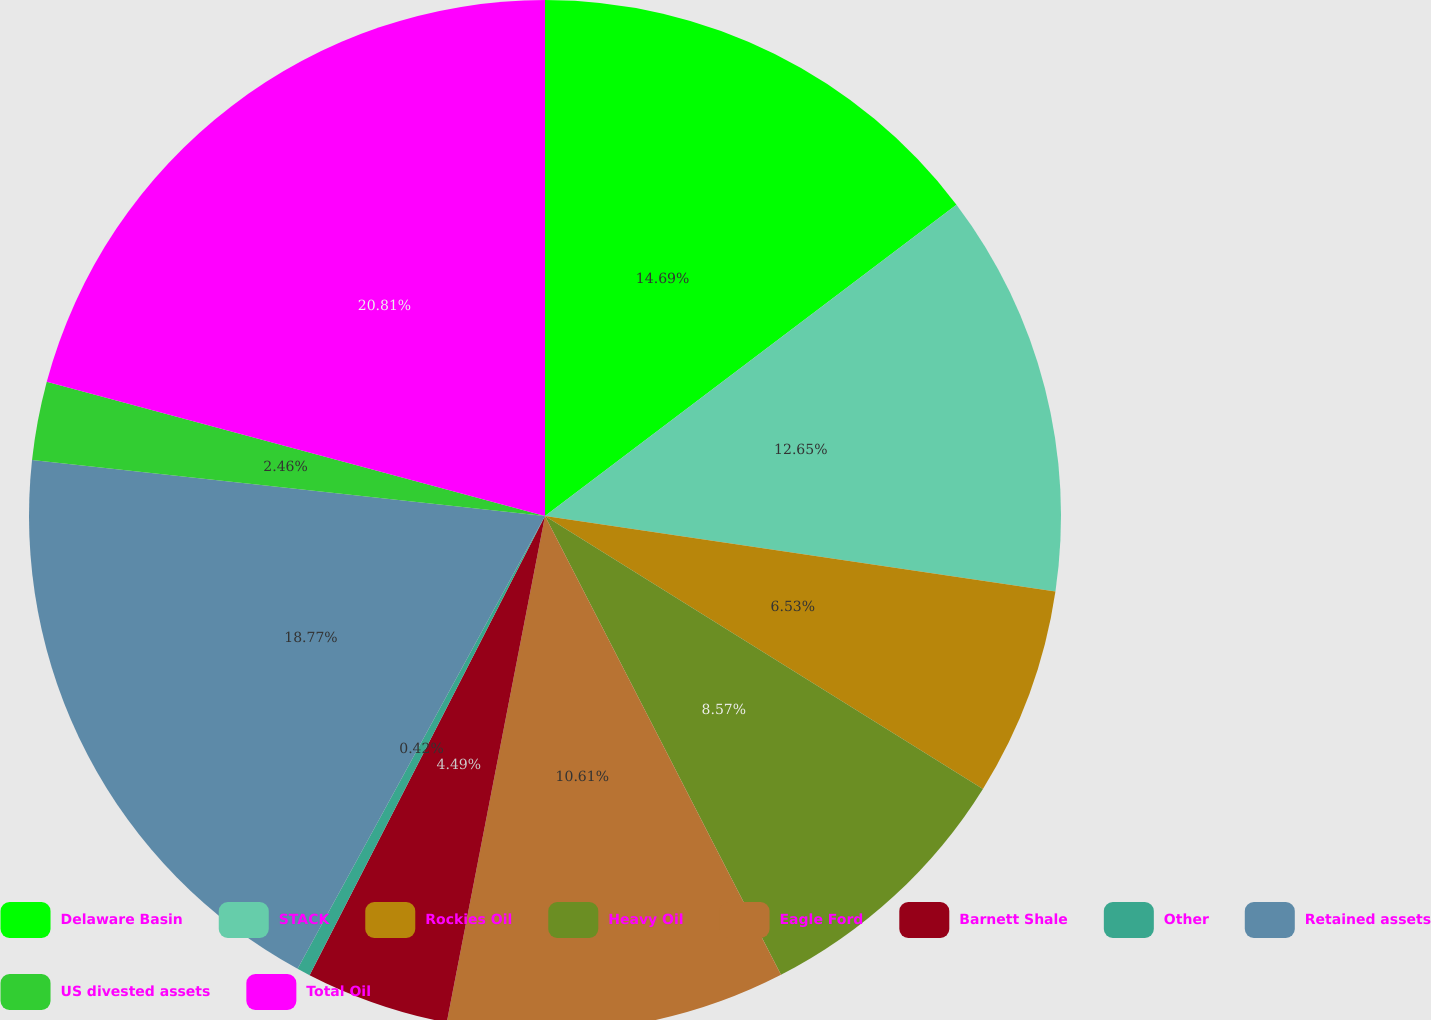<chart> <loc_0><loc_0><loc_500><loc_500><pie_chart><fcel>Delaware Basin<fcel>STACK<fcel>Rockies Oil<fcel>Heavy Oil<fcel>Eagle Ford<fcel>Barnett Shale<fcel>Other<fcel>Retained assets<fcel>US divested assets<fcel>Total Oil<nl><fcel>14.69%<fcel>12.65%<fcel>6.53%<fcel>8.57%<fcel>10.61%<fcel>4.49%<fcel>0.42%<fcel>18.77%<fcel>2.46%<fcel>20.81%<nl></chart> 